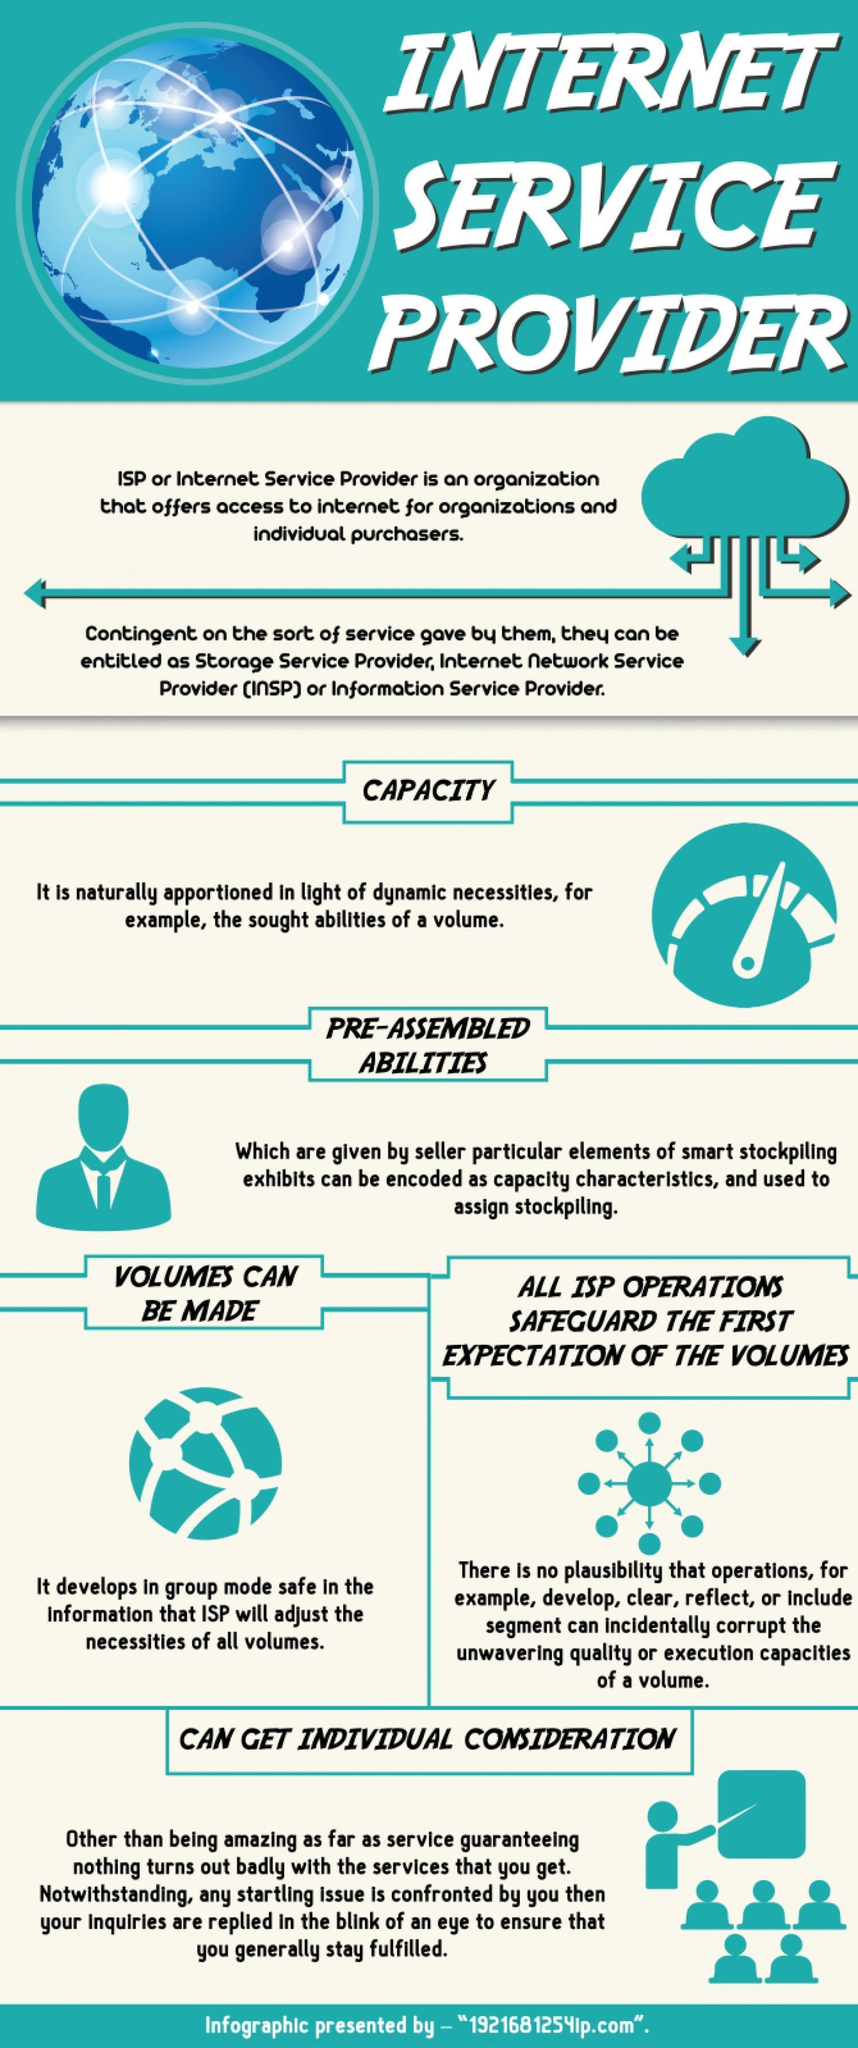What can be entitled as storage service provider or internet network service provider based on the type of service?
Answer the question with a short phrase. ISP 